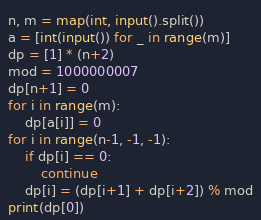<code> <loc_0><loc_0><loc_500><loc_500><_Python_>n, m = map(int, input().split())
a = [int(input()) for _ in range(m)]
dp = [1] * (n+2)
mod = 1000000007
dp[n+1] = 0
for i in range(m):
    dp[a[i]] = 0
for i in range(n-1, -1, -1):
    if dp[i] == 0:
        continue
    dp[i] = (dp[i+1] + dp[i+2]) % mod
print(dp[0])</code> 